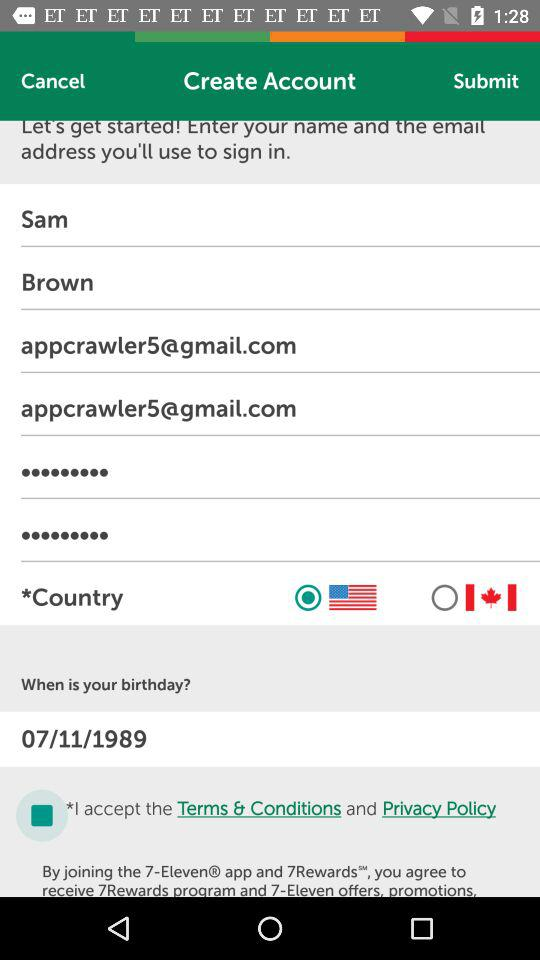Which country is selected? The selected country is the USA. 